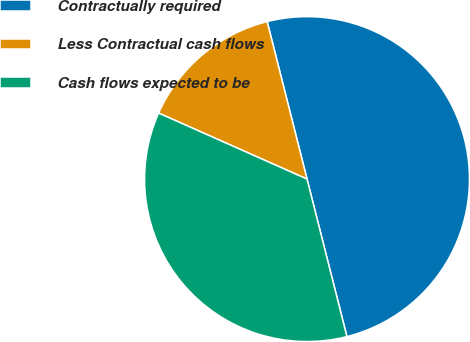<chart> <loc_0><loc_0><loc_500><loc_500><pie_chart><fcel>Contractually required<fcel>Less Contractual cash flows<fcel>Cash flows expected to be<nl><fcel>50.0%<fcel>14.39%<fcel>35.61%<nl></chart> 